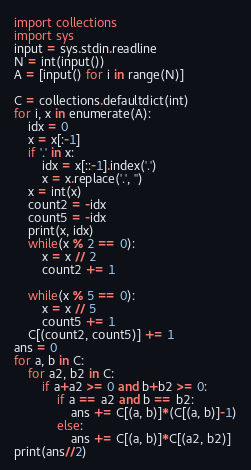Convert code to text. <code><loc_0><loc_0><loc_500><loc_500><_Python_>import collections
import sys
input = sys.stdin.readline
N = int(input())
A = [input() for i in range(N)]

C = collections.defaultdict(int)
for i, x in enumerate(A):
    idx = 0
    x = x[:-1]
    if '.' in x:
        idx = x[::-1].index('.')
        x = x.replace('.', '')
    x = int(x)
    count2 = -idx
    count5 = -idx
    print(x, idx)
    while(x % 2 == 0):
        x = x // 2
        count2 += 1

    while(x % 5 == 0):
        x = x // 5
        count5 += 1
    C[(count2, count5)] += 1
ans = 0
for a, b in C:
    for a2, b2 in C:
        if a+a2 >= 0 and b+b2 >= 0:
            if a == a2 and b == b2:
                ans += C[(a, b)]*(C[(a, b)]-1)
            else:
                ans += C[(a, b)]*C[(a2, b2)]
print(ans//2)
</code> 